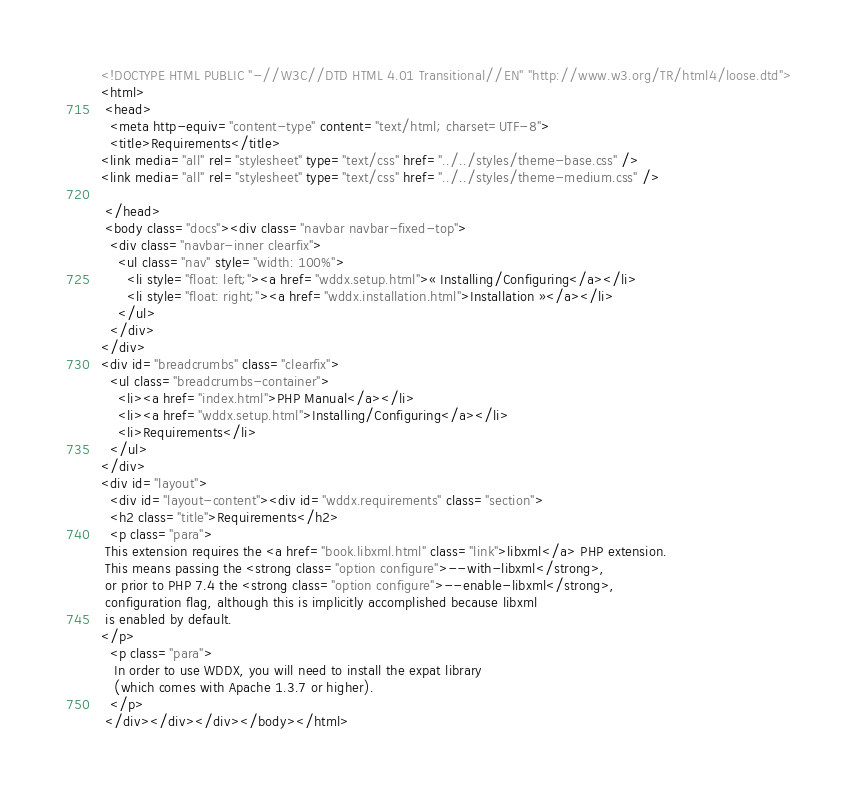<code> <loc_0><loc_0><loc_500><loc_500><_HTML_><!DOCTYPE HTML PUBLIC "-//W3C//DTD HTML 4.01 Transitional//EN" "http://www.w3.org/TR/html4/loose.dtd">
<html>
 <head>
  <meta http-equiv="content-type" content="text/html; charset=UTF-8">
  <title>Requirements</title>
<link media="all" rel="stylesheet" type="text/css" href="../../styles/theme-base.css" />
<link media="all" rel="stylesheet" type="text/css" href="../../styles/theme-medium.css" />

 </head>
 <body class="docs"><div class="navbar navbar-fixed-top">
  <div class="navbar-inner clearfix">
    <ul class="nav" style="width: 100%">
      <li style="float: left;"><a href="wddx.setup.html">« Installing/Configuring</a></li>
      <li style="float: right;"><a href="wddx.installation.html">Installation »</a></li>
    </ul>
  </div>
</div>
<div id="breadcrumbs" class="clearfix">
  <ul class="breadcrumbs-container">
    <li><a href="index.html">PHP Manual</a></li>
    <li><a href="wddx.setup.html">Installing/Configuring</a></li>
    <li>Requirements</li>
  </ul>
</div>
<div id="layout">
  <div id="layout-content"><div id="wddx.requirements" class="section">
  <h2 class="title">Requirements</h2>
  <p class="para">
 This extension requires the <a href="book.libxml.html" class="link">libxml</a> PHP extension.
 This means passing the <strong class="option configure">--with-libxml</strong>,
 or prior to PHP 7.4 the <strong class="option configure">--enable-libxml</strong>,
 configuration flag, although this is implicitly accomplished because libxml
 is enabled by default.
</p>
  <p class="para">
   In order to use WDDX, you will need to install the expat library
   (which comes with Apache 1.3.7 or higher).
  </p>
 </div></div></div></body></html></code> 